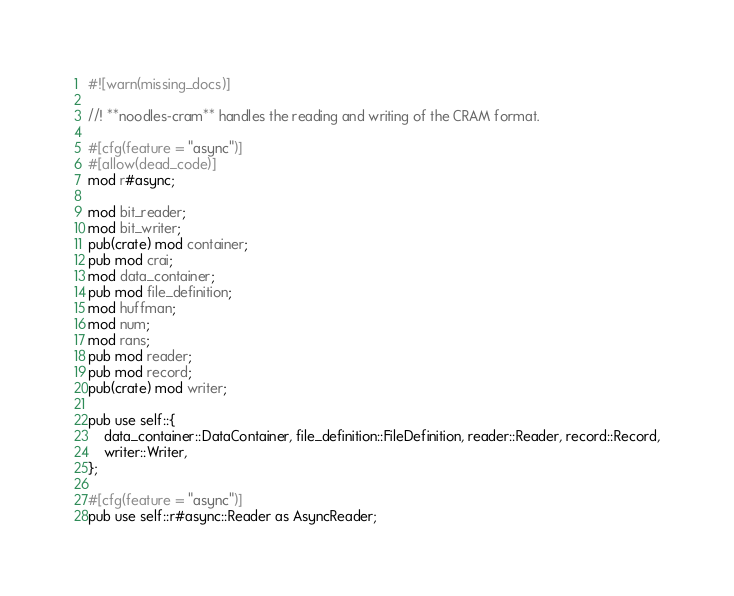Convert code to text. <code><loc_0><loc_0><loc_500><loc_500><_Rust_>#![warn(missing_docs)]

//! **noodles-cram** handles the reading and writing of the CRAM format.

#[cfg(feature = "async")]
#[allow(dead_code)]
mod r#async;

mod bit_reader;
mod bit_writer;
pub(crate) mod container;
pub mod crai;
mod data_container;
pub mod file_definition;
mod huffman;
mod num;
mod rans;
pub mod reader;
pub mod record;
pub(crate) mod writer;

pub use self::{
    data_container::DataContainer, file_definition::FileDefinition, reader::Reader, record::Record,
    writer::Writer,
};

#[cfg(feature = "async")]
pub use self::r#async::Reader as AsyncReader;
</code> 